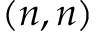<formula> <loc_0><loc_0><loc_500><loc_500>( n , n )</formula> 